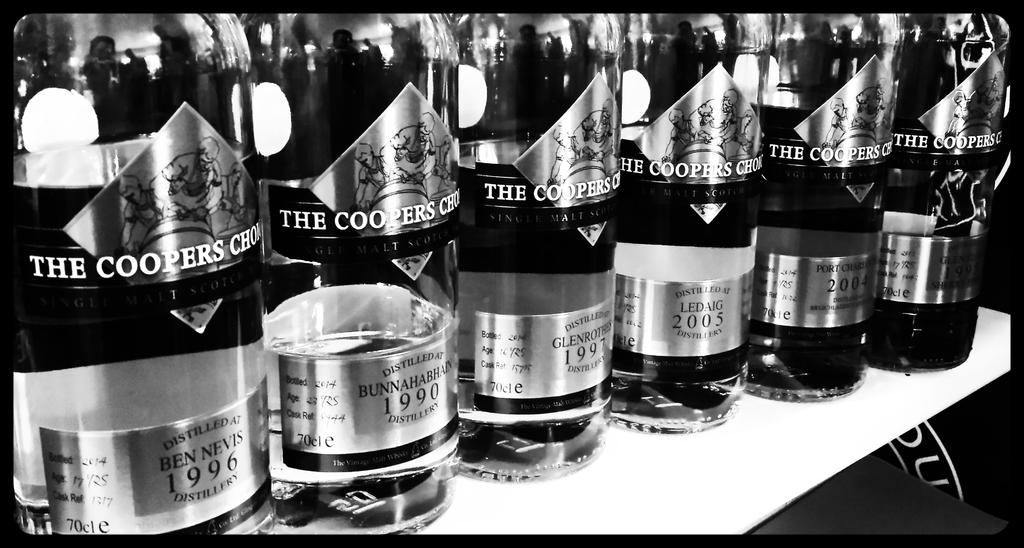<image>
Offer a succinct explanation of the picture presented. 6 bottles of The Coopers Choice Whisky lined up from 1996, 1990, 1997, 2005, 2004. 